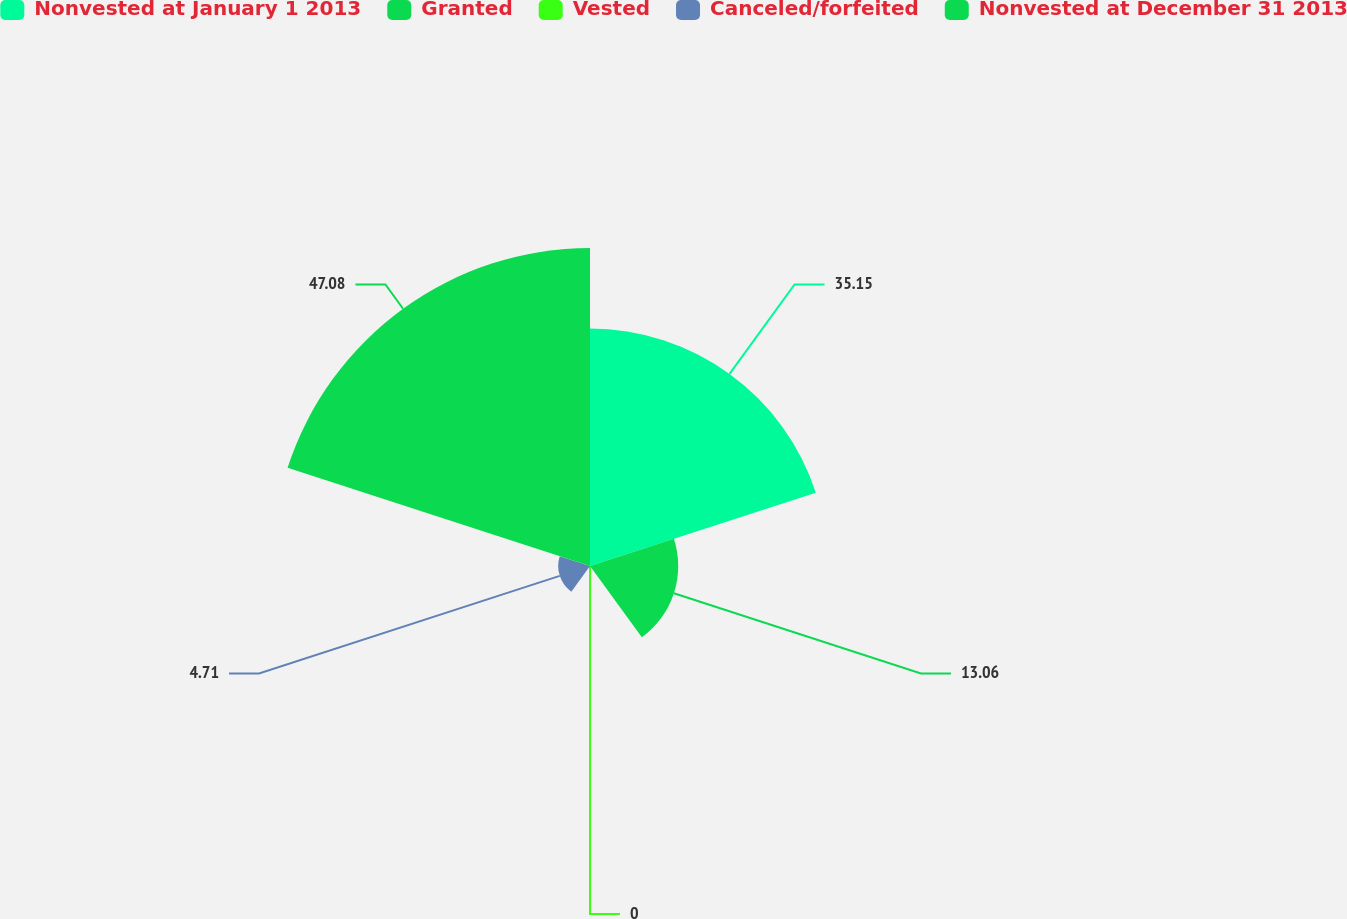<chart> <loc_0><loc_0><loc_500><loc_500><pie_chart><fcel>Nonvested at January 1 2013<fcel>Granted<fcel>Vested<fcel>Canceled/forfeited<fcel>Nonvested at December 31 2013<nl><fcel>35.15%<fcel>13.06%<fcel>0.0%<fcel>4.71%<fcel>47.08%<nl></chart> 